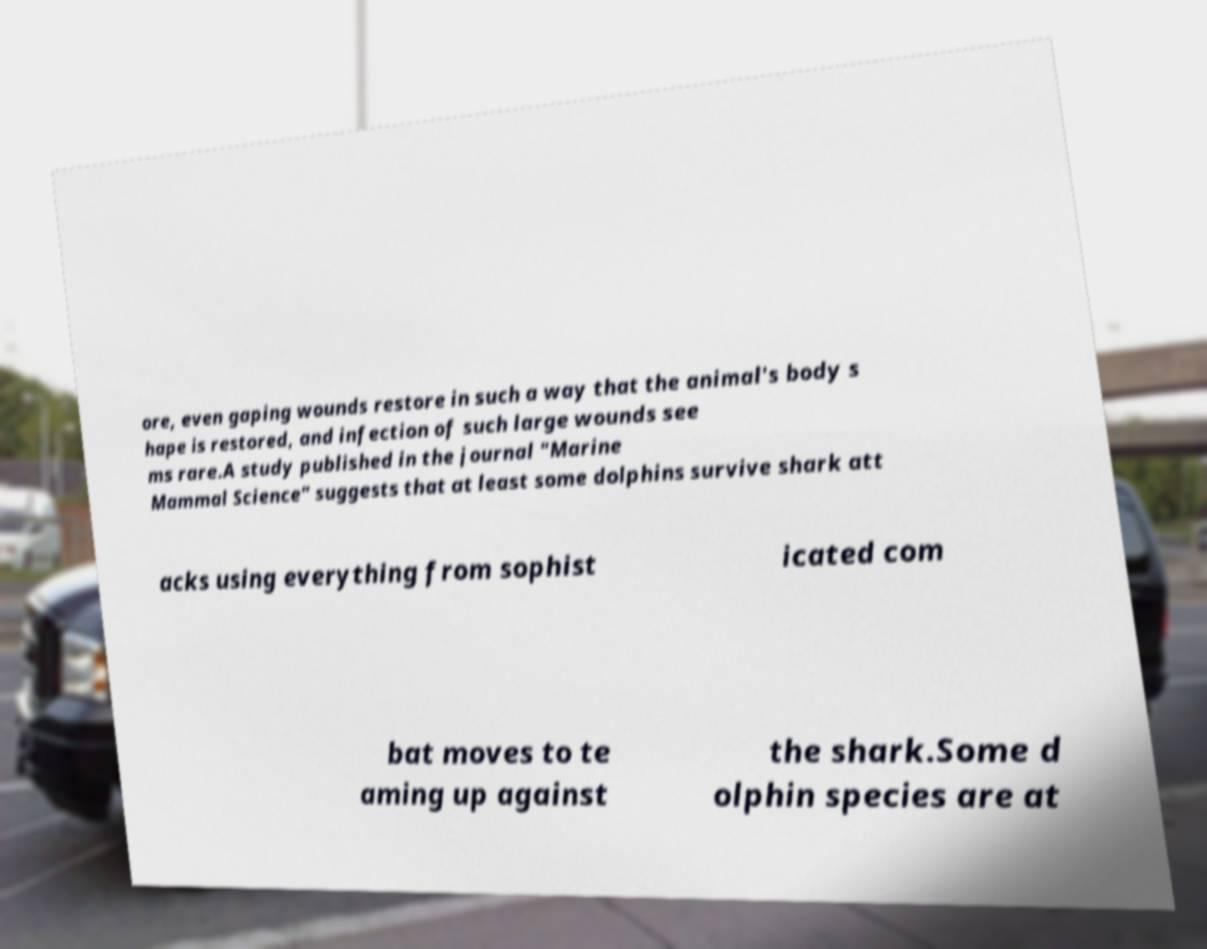What messages or text are displayed in this image? I need them in a readable, typed format. ore, even gaping wounds restore in such a way that the animal's body s hape is restored, and infection of such large wounds see ms rare.A study published in the journal "Marine Mammal Science" suggests that at least some dolphins survive shark att acks using everything from sophist icated com bat moves to te aming up against the shark.Some d olphin species are at 